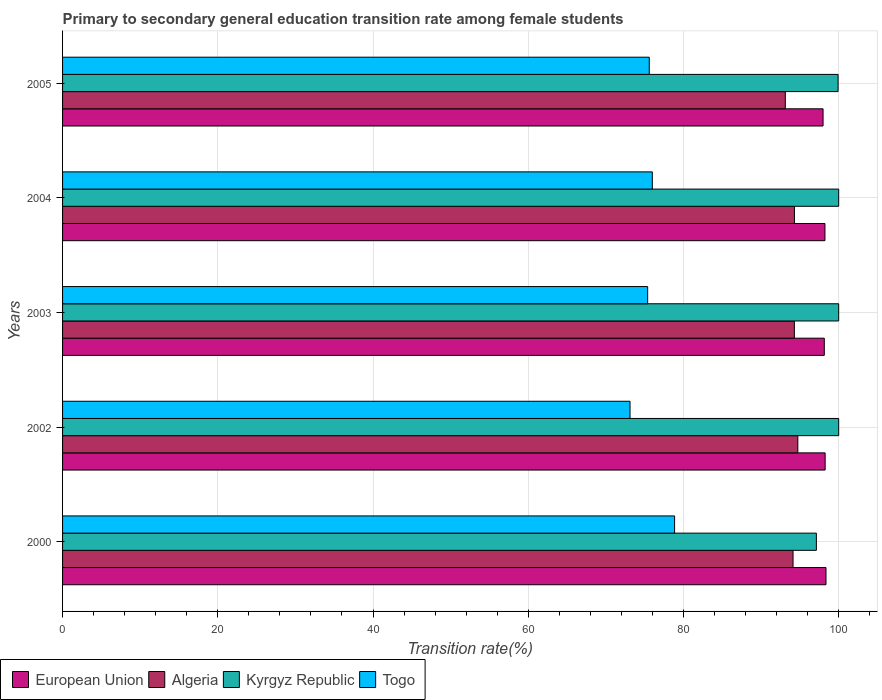What is the label of the 3rd group of bars from the top?
Make the answer very short. 2003. What is the transition rate in Algeria in 2003?
Provide a succinct answer. 94.29. Across all years, what is the maximum transition rate in Togo?
Your response must be concise. 78.86. Across all years, what is the minimum transition rate in European Union?
Ensure brevity in your answer.  97.99. In which year was the transition rate in Kyrgyz Republic maximum?
Your answer should be very brief. 2002. In which year was the transition rate in Togo minimum?
Give a very brief answer. 2002. What is the total transition rate in Kyrgyz Republic in the graph?
Keep it short and to the point. 497.05. What is the difference between the transition rate in Togo in 2003 and that in 2004?
Your answer should be very brief. -0.6. What is the difference between the transition rate in Kyrgyz Republic in 2004 and the transition rate in Algeria in 2003?
Your answer should be very brief. 5.71. What is the average transition rate in European Union per year?
Your response must be concise. 98.2. In the year 2005, what is the difference between the transition rate in Kyrgyz Republic and transition rate in European Union?
Provide a succinct answer. 1.94. What is the ratio of the transition rate in European Union in 2000 to that in 2002?
Offer a terse response. 1. What is the difference between the highest and the second highest transition rate in European Union?
Your answer should be compact. 0.11. What is the difference between the highest and the lowest transition rate in Kyrgyz Republic?
Keep it short and to the point. 2.87. In how many years, is the transition rate in European Union greater than the average transition rate in European Union taken over all years?
Your answer should be very brief. 3. Is it the case that in every year, the sum of the transition rate in European Union and transition rate in Algeria is greater than the sum of transition rate in Togo and transition rate in Kyrgyz Republic?
Ensure brevity in your answer.  No. What does the 2nd bar from the top in 2002 represents?
Provide a short and direct response. Kyrgyz Republic. How many bars are there?
Your answer should be compact. 20. What is the difference between two consecutive major ticks on the X-axis?
Your answer should be compact. 20. Are the values on the major ticks of X-axis written in scientific E-notation?
Your answer should be very brief. No. Does the graph contain any zero values?
Your answer should be compact. No. Does the graph contain grids?
Give a very brief answer. Yes. What is the title of the graph?
Ensure brevity in your answer.  Primary to secondary general education transition rate among female students. What is the label or title of the X-axis?
Offer a very short reply. Transition rate(%). What is the label or title of the Y-axis?
Provide a short and direct response. Years. What is the Transition rate(%) in European Union in 2000?
Keep it short and to the point. 98.37. What is the Transition rate(%) of Algeria in 2000?
Your answer should be very brief. 94.12. What is the Transition rate(%) of Kyrgyz Republic in 2000?
Keep it short and to the point. 97.13. What is the Transition rate(%) in Togo in 2000?
Make the answer very short. 78.86. What is the Transition rate(%) of European Union in 2002?
Your answer should be compact. 98.26. What is the Transition rate(%) of Algeria in 2002?
Your response must be concise. 94.74. What is the Transition rate(%) of Togo in 2002?
Offer a terse response. 73.12. What is the Transition rate(%) of European Union in 2003?
Give a very brief answer. 98.15. What is the Transition rate(%) of Algeria in 2003?
Offer a very short reply. 94.29. What is the Transition rate(%) in Togo in 2003?
Make the answer very short. 75.39. What is the Transition rate(%) of European Union in 2004?
Your answer should be compact. 98.23. What is the Transition rate(%) in Algeria in 2004?
Offer a terse response. 94.3. What is the Transition rate(%) of Kyrgyz Republic in 2004?
Keep it short and to the point. 100. What is the Transition rate(%) of Togo in 2004?
Ensure brevity in your answer.  75.99. What is the Transition rate(%) of European Union in 2005?
Give a very brief answer. 97.99. What is the Transition rate(%) of Algeria in 2005?
Give a very brief answer. 93.12. What is the Transition rate(%) of Kyrgyz Republic in 2005?
Ensure brevity in your answer.  99.92. What is the Transition rate(%) of Togo in 2005?
Offer a very short reply. 75.59. Across all years, what is the maximum Transition rate(%) of European Union?
Your answer should be compact. 98.37. Across all years, what is the maximum Transition rate(%) of Algeria?
Offer a terse response. 94.74. Across all years, what is the maximum Transition rate(%) of Togo?
Keep it short and to the point. 78.86. Across all years, what is the minimum Transition rate(%) in European Union?
Your answer should be compact. 97.99. Across all years, what is the minimum Transition rate(%) in Algeria?
Your answer should be very brief. 93.12. Across all years, what is the minimum Transition rate(%) in Kyrgyz Republic?
Offer a terse response. 97.13. Across all years, what is the minimum Transition rate(%) in Togo?
Offer a very short reply. 73.12. What is the total Transition rate(%) of European Union in the graph?
Your answer should be very brief. 490.98. What is the total Transition rate(%) of Algeria in the graph?
Ensure brevity in your answer.  470.57. What is the total Transition rate(%) in Kyrgyz Republic in the graph?
Your answer should be very brief. 497.05. What is the total Transition rate(%) of Togo in the graph?
Your answer should be compact. 378.94. What is the difference between the Transition rate(%) in European Union in 2000 and that in 2002?
Keep it short and to the point. 0.11. What is the difference between the Transition rate(%) in Algeria in 2000 and that in 2002?
Offer a terse response. -0.62. What is the difference between the Transition rate(%) of Kyrgyz Republic in 2000 and that in 2002?
Make the answer very short. -2.87. What is the difference between the Transition rate(%) of Togo in 2000 and that in 2002?
Provide a succinct answer. 5.74. What is the difference between the Transition rate(%) of European Union in 2000 and that in 2003?
Ensure brevity in your answer.  0.22. What is the difference between the Transition rate(%) in Algeria in 2000 and that in 2003?
Make the answer very short. -0.17. What is the difference between the Transition rate(%) of Kyrgyz Republic in 2000 and that in 2003?
Provide a succinct answer. -2.87. What is the difference between the Transition rate(%) of Togo in 2000 and that in 2003?
Your answer should be compact. 3.47. What is the difference between the Transition rate(%) of European Union in 2000 and that in 2004?
Offer a very short reply. 0.13. What is the difference between the Transition rate(%) in Algeria in 2000 and that in 2004?
Your response must be concise. -0.18. What is the difference between the Transition rate(%) in Kyrgyz Republic in 2000 and that in 2004?
Your answer should be compact. -2.87. What is the difference between the Transition rate(%) in Togo in 2000 and that in 2004?
Your answer should be very brief. 2.87. What is the difference between the Transition rate(%) of European Union in 2000 and that in 2005?
Your answer should be very brief. 0.38. What is the difference between the Transition rate(%) of Algeria in 2000 and that in 2005?
Give a very brief answer. 1. What is the difference between the Transition rate(%) in Kyrgyz Republic in 2000 and that in 2005?
Give a very brief answer. -2.8. What is the difference between the Transition rate(%) in Togo in 2000 and that in 2005?
Ensure brevity in your answer.  3.26. What is the difference between the Transition rate(%) of European Union in 2002 and that in 2003?
Make the answer very short. 0.11. What is the difference between the Transition rate(%) of Algeria in 2002 and that in 2003?
Your answer should be compact. 0.45. What is the difference between the Transition rate(%) in Kyrgyz Republic in 2002 and that in 2003?
Provide a succinct answer. 0. What is the difference between the Transition rate(%) of Togo in 2002 and that in 2003?
Your answer should be compact. -2.27. What is the difference between the Transition rate(%) in European Union in 2002 and that in 2004?
Offer a very short reply. 0.02. What is the difference between the Transition rate(%) in Algeria in 2002 and that in 2004?
Give a very brief answer. 0.44. What is the difference between the Transition rate(%) of Kyrgyz Republic in 2002 and that in 2004?
Provide a succinct answer. 0. What is the difference between the Transition rate(%) of Togo in 2002 and that in 2004?
Provide a succinct answer. -2.87. What is the difference between the Transition rate(%) of European Union in 2002 and that in 2005?
Ensure brevity in your answer.  0.27. What is the difference between the Transition rate(%) of Algeria in 2002 and that in 2005?
Ensure brevity in your answer.  1.61. What is the difference between the Transition rate(%) in Kyrgyz Republic in 2002 and that in 2005?
Your answer should be very brief. 0.08. What is the difference between the Transition rate(%) of Togo in 2002 and that in 2005?
Make the answer very short. -2.48. What is the difference between the Transition rate(%) of European Union in 2003 and that in 2004?
Make the answer very short. -0.09. What is the difference between the Transition rate(%) of Algeria in 2003 and that in 2004?
Your answer should be very brief. -0.01. What is the difference between the Transition rate(%) of Togo in 2003 and that in 2004?
Your answer should be compact. -0.6. What is the difference between the Transition rate(%) of European Union in 2003 and that in 2005?
Your answer should be very brief. 0.16. What is the difference between the Transition rate(%) of Algeria in 2003 and that in 2005?
Your response must be concise. 1.17. What is the difference between the Transition rate(%) of Kyrgyz Republic in 2003 and that in 2005?
Provide a short and direct response. 0.08. What is the difference between the Transition rate(%) of Togo in 2003 and that in 2005?
Ensure brevity in your answer.  -0.21. What is the difference between the Transition rate(%) in European Union in 2004 and that in 2005?
Provide a succinct answer. 0.25. What is the difference between the Transition rate(%) in Algeria in 2004 and that in 2005?
Your answer should be compact. 1.18. What is the difference between the Transition rate(%) of Kyrgyz Republic in 2004 and that in 2005?
Ensure brevity in your answer.  0.08. What is the difference between the Transition rate(%) of Togo in 2004 and that in 2005?
Give a very brief answer. 0.39. What is the difference between the Transition rate(%) in European Union in 2000 and the Transition rate(%) in Algeria in 2002?
Provide a succinct answer. 3.63. What is the difference between the Transition rate(%) in European Union in 2000 and the Transition rate(%) in Kyrgyz Republic in 2002?
Your answer should be very brief. -1.63. What is the difference between the Transition rate(%) of European Union in 2000 and the Transition rate(%) of Togo in 2002?
Ensure brevity in your answer.  25.25. What is the difference between the Transition rate(%) in Algeria in 2000 and the Transition rate(%) in Kyrgyz Republic in 2002?
Make the answer very short. -5.88. What is the difference between the Transition rate(%) of Algeria in 2000 and the Transition rate(%) of Togo in 2002?
Provide a short and direct response. 21. What is the difference between the Transition rate(%) of Kyrgyz Republic in 2000 and the Transition rate(%) of Togo in 2002?
Your answer should be very brief. 24.01. What is the difference between the Transition rate(%) of European Union in 2000 and the Transition rate(%) of Algeria in 2003?
Your answer should be compact. 4.08. What is the difference between the Transition rate(%) in European Union in 2000 and the Transition rate(%) in Kyrgyz Republic in 2003?
Provide a succinct answer. -1.63. What is the difference between the Transition rate(%) in European Union in 2000 and the Transition rate(%) in Togo in 2003?
Ensure brevity in your answer.  22.98. What is the difference between the Transition rate(%) of Algeria in 2000 and the Transition rate(%) of Kyrgyz Republic in 2003?
Your answer should be very brief. -5.88. What is the difference between the Transition rate(%) in Algeria in 2000 and the Transition rate(%) in Togo in 2003?
Provide a short and direct response. 18.73. What is the difference between the Transition rate(%) in Kyrgyz Republic in 2000 and the Transition rate(%) in Togo in 2003?
Provide a succinct answer. 21.74. What is the difference between the Transition rate(%) of European Union in 2000 and the Transition rate(%) of Algeria in 2004?
Make the answer very short. 4.07. What is the difference between the Transition rate(%) of European Union in 2000 and the Transition rate(%) of Kyrgyz Republic in 2004?
Provide a short and direct response. -1.63. What is the difference between the Transition rate(%) in European Union in 2000 and the Transition rate(%) in Togo in 2004?
Your answer should be compact. 22.38. What is the difference between the Transition rate(%) of Algeria in 2000 and the Transition rate(%) of Kyrgyz Republic in 2004?
Give a very brief answer. -5.88. What is the difference between the Transition rate(%) in Algeria in 2000 and the Transition rate(%) in Togo in 2004?
Your answer should be very brief. 18.13. What is the difference between the Transition rate(%) in Kyrgyz Republic in 2000 and the Transition rate(%) in Togo in 2004?
Offer a terse response. 21.14. What is the difference between the Transition rate(%) in European Union in 2000 and the Transition rate(%) in Algeria in 2005?
Your response must be concise. 5.24. What is the difference between the Transition rate(%) in European Union in 2000 and the Transition rate(%) in Kyrgyz Republic in 2005?
Give a very brief answer. -1.56. What is the difference between the Transition rate(%) in European Union in 2000 and the Transition rate(%) in Togo in 2005?
Your response must be concise. 22.77. What is the difference between the Transition rate(%) in Algeria in 2000 and the Transition rate(%) in Kyrgyz Republic in 2005?
Offer a terse response. -5.8. What is the difference between the Transition rate(%) in Algeria in 2000 and the Transition rate(%) in Togo in 2005?
Your response must be concise. 18.53. What is the difference between the Transition rate(%) of Kyrgyz Republic in 2000 and the Transition rate(%) of Togo in 2005?
Give a very brief answer. 21.53. What is the difference between the Transition rate(%) of European Union in 2002 and the Transition rate(%) of Algeria in 2003?
Give a very brief answer. 3.97. What is the difference between the Transition rate(%) of European Union in 2002 and the Transition rate(%) of Kyrgyz Republic in 2003?
Your response must be concise. -1.74. What is the difference between the Transition rate(%) of European Union in 2002 and the Transition rate(%) of Togo in 2003?
Keep it short and to the point. 22.87. What is the difference between the Transition rate(%) in Algeria in 2002 and the Transition rate(%) in Kyrgyz Republic in 2003?
Offer a very short reply. -5.26. What is the difference between the Transition rate(%) in Algeria in 2002 and the Transition rate(%) in Togo in 2003?
Your response must be concise. 19.35. What is the difference between the Transition rate(%) in Kyrgyz Republic in 2002 and the Transition rate(%) in Togo in 2003?
Your answer should be very brief. 24.61. What is the difference between the Transition rate(%) in European Union in 2002 and the Transition rate(%) in Algeria in 2004?
Give a very brief answer. 3.96. What is the difference between the Transition rate(%) in European Union in 2002 and the Transition rate(%) in Kyrgyz Republic in 2004?
Provide a succinct answer. -1.74. What is the difference between the Transition rate(%) of European Union in 2002 and the Transition rate(%) of Togo in 2004?
Offer a terse response. 22.27. What is the difference between the Transition rate(%) in Algeria in 2002 and the Transition rate(%) in Kyrgyz Republic in 2004?
Make the answer very short. -5.26. What is the difference between the Transition rate(%) in Algeria in 2002 and the Transition rate(%) in Togo in 2004?
Offer a very short reply. 18.75. What is the difference between the Transition rate(%) of Kyrgyz Republic in 2002 and the Transition rate(%) of Togo in 2004?
Your response must be concise. 24.01. What is the difference between the Transition rate(%) of European Union in 2002 and the Transition rate(%) of Algeria in 2005?
Give a very brief answer. 5.13. What is the difference between the Transition rate(%) in European Union in 2002 and the Transition rate(%) in Kyrgyz Republic in 2005?
Make the answer very short. -1.67. What is the difference between the Transition rate(%) in European Union in 2002 and the Transition rate(%) in Togo in 2005?
Ensure brevity in your answer.  22.66. What is the difference between the Transition rate(%) in Algeria in 2002 and the Transition rate(%) in Kyrgyz Republic in 2005?
Keep it short and to the point. -5.19. What is the difference between the Transition rate(%) in Algeria in 2002 and the Transition rate(%) in Togo in 2005?
Offer a terse response. 19.14. What is the difference between the Transition rate(%) in Kyrgyz Republic in 2002 and the Transition rate(%) in Togo in 2005?
Keep it short and to the point. 24.41. What is the difference between the Transition rate(%) in European Union in 2003 and the Transition rate(%) in Algeria in 2004?
Offer a terse response. 3.85. What is the difference between the Transition rate(%) of European Union in 2003 and the Transition rate(%) of Kyrgyz Republic in 2004?
Provide a succinct answer. -1.85. What is the difference between the Transition rate(%) of European Union in 2003 and the Transition rate(%) of Togo in 2004?
Provide a succinct answer. 22.16. What is the difference between the Transition rate(%) of Algeria in 2003 and the Transition rate(%) of Kyrgyz Republic in 2004?
Your response must be concise. -5.71. What is the difference between the Transition rate(%) in Algeria in 2003 and the Transition rate(%) in Togo in 2004?
Provide a succinct answer. 18.3. What is the difference between the Transition rate(%) in Kyrgyz Republic in 2003 and the Transition rate(%) in Togo in 2004?
Provide a succinct answer. 24.01. What is the difference between the Transition rate(%) in European Union in 2003 and the Transition rate(%) in Algeria in 2005?
Your answer should be very brief. 5.02. What is the difference between the Transition rate(%) of European Union in 2003 and the Transition rate(%) of Kyrgyz Republic in 2005?
Make the answer very short. -1.78. What is the difference between the Transition rate(%) of European Union in 2003 and the Transition rate(%) of Togo in 2005?
Offer a very short reply. 22.55. What is the difference between the Transition rate(%) in Algeria in 2003 and the Transition rate(%) in Kyrgyz Republic in 2005?
Your answer should be very brief. -5.63. What is the difference between the Transition rate(%) in Algeria in 2003 and the Transition rate(%) in Togo in 2005?
Keep it short and to the point. 18.7. What is the difference between the Transition rate(%) in Kyrgyz Republic in 2003 and the Transition rate(%) in Togo in 2005?
Offer a terse response. 24.41. What is the difference between the Transition rate(%) of European Union in 2004 and the Transition rate(%) of Algeria in 2005?
Your answer should be compact. 5.11. What is the difference between the Transition rate(%) of European Union in 2004 and the Transition rate(%) of Kyrgyz Republic in 2005?
Provide a succinct answer. -1.69. What is the difference between the Transition rate(%) of European Union in 2004 and the Transition rate(%) of Togo in 2005?
Provide a succinct answer. 22.64. What is the difference between the Transition rate(%) of Algeria in 2004 and the Transition rate(%) of Kyrgyz Republic in 2005?
Make the answer very short. -5.63. What is the difference between the Transition rate(%) of Algeria in 2004 and the Transition rate(%) of Togo in 2005?
Keep it short and to the point. 18.7. What is the difference between the Transition rate(%) in Kyrgyz Republic in 2004 and the Transition rate(%) in Togo in 2005?
Your answer should be very brief. 24.41. What is the average Transition rate(%) of European Union per year?
Provide a short and direct response. 98.2. What is the average Transition rate(%) of Algeria per year?
Your answer should be compact. 94.11. What is the average Transition rate(%) of Kyrgyz Republic per year?
Offer a very short reply. 99.41. What is the average Transition rate(%) of Togo per year?
Give a very brief answer. 75.79. In the year 2000, what is the difference between the Transition rate(%) of European Union and Transition rate(%) of Algeria?
Give a very brief answer. 4.25. In the year 2000, what is the difference between the Transition rate(%) of European Union and Transition rate(%) of Kyrgyz Republic?
Make the answer very short. 1.24. In the year 2000, what is the difference between the Transition rate(%) of European Union and Transition rate(%) of Togo?
Offer a very short reply. 19.51. In the year 2000, what is the difference between the Transition rate(%) in Algeria and Transition rate(%) in Kyrgyz Republic?
Provide a short and direct response. -3. In the year 2000, what is the difference between the Transition rate(%) of Algeria and Transition rate(%) of Togo?
Your answer should be compact. 15.26. In the year 2000, what is the difference between the Transition rate(%) of Kyrgyz Republic and Transition rate(%) of Togo?
Give a very brief answer. 18.27. In the year 2002, what is the difference between the Transition rate(%) in European Union and Transition rate(%) in Algeria?
Provide a short and direct response. 3.52. In the year 2002, what is the difference between the Transition rate(%) of European Union and Transition rate(%) of Kyrgyz Republic?
Give a very brief answer. -1.74. In the year 2002, what is the difference between the Transition rate(%) in European Union and Transition rate(%) in Togo?
Make the answer very short. 25.14. In the year 2002, what is the difference between the Transition rate(%) in Algeria and Transition rate(%) in Kyrgyz Republic?
Ensure brevity in your answer.  -5.26. In the year 2002, what is the difference between the Transition rate(%) of Algeria and Transition rate(%) of Togo?
Keep it short and to the point. 21.62. In the year 2002, what is the difference between the Transition rate(%) in Kyrgyz Republic and Transition rate(%) in Togo?
Your answer should be compact. 26.88. In the year 2003, what is the difference between the Transition rate(%) in European Union and Transition rate(%) in Algeria?
Make the answer very short. 3.86. In the year 2003, what is the difference between the Transition rate(%) of European Union and Transition rate(%) of Kyrgyz Republic?
Ensure brevity in your answer.  -1.85. In the year 2003, what is the difference between the Transition rate(%) in European Union and Transition rate(%) in Togo?
Ensure brevity in your answer.  22.76. In the year 2003, what is the difference between the Transition rate(%) in Algeria and Transition rate(%) in Kyrgyz Republic?
Your response must be concise. -5.71. In the year 2003, what is the difference between the Transition rate(%) of Algeria and Transition rate(%) of Togo?
Your answer should be compact. 18.9. In the year 2003, what is the difference between the Transition rate(%) in Kyrgyz Republic and Transition rate(%) in Togo?
Keep it short and to the point. 24.61. In the year 2004, what is the difference between the Transition rate(%) in European Union and Transition rate(%) in Algeria?
Your answer should be compact. 3.93. In the year 2004, what is the difference between the Transition rate(%) in European Union and Transition rate(%) in Kyrgyz Republic?
Your response must be concise. -1.77. In the year 2004, what is the difference between the Transition rate(%) of European Union and Transition rate(%) of Togo?
Provide a succinct answer. 22.24. In the year 2004, what is the difference between the Transition rate(%) of Algeria and Transition rate(%) of Kyrgyz Republic?
Provide a succinct answer. -5.7. In the year 2004, what is the difference between the Transition rate(%) of Algeria and Transition rate(%) of Togo?
Ensure brevity in your answer.  18.31. In the year 2004, what is the difference between the Transition rate(%) in Kyrgyz Republic and Transition rate(%) in Togo?
Provide a succinct answer. 24.01. In the year 2005, what is the difference between the Transition rate(%) in European Union and Transition rate(%) in Algeria?
Provide a short and direct response. 4.86. In the year 2005, what is the difference between the Transition rate(%) of European Union and Transition rate(%) of Kyrgyz Republic?
Your response must be concise. -1.94. In the year 2005, what is the difference between the Transition rate(%) of European Union and Transition rate(%) of Togo?
Your response must be concise. 22.39. In the year 2005, what is the difference between the Transition rate(%) in Algeria and Transition rate(%) in Kyrgyz Republic?
Offer a terse response. -6.8. In the year 2005, what is the difference between the Transition rate(%) of Algeria and Transition rate(%) of Togo?
Your response must be concise. 17.53. In the year 2005, what is the difference between the Transition rate(%) of Kyrgyz Republic and Transition rate(%) of Togo?
Provide a succinct answer. 24.33. What is the ratio of the Transition rate(%) of Algeria in 2000 to that in 2002?
Offer a very short reply. 0.99. What is the ratio of the Transition rate(%) in Kyrgyz Republic in 2000 to that in 2002?
Give a very brief answer. 0.97. What is the ratio of the Transition rate(%) of Togo in 2000 to that in 2002?
Provide a succinct answer. 1.08. What is the ratio of the Transition rate(%) of European Union in 2000 to that in 2003?
Keep it short and to the point. 1. What is the ratio of the Transition rate(%) in Kyrgyz Republic in 2000 to that in 2003?
Ensure brevity in your answer.  0.97. What is the ratio of the Transition rate(%) in Togo in 2000 to that in 2003?
Keep it short and to the point. 1.05. What is the ratio of the Transition rate(%) of European Union in 2000 to that in 2004?
Your response must be concise. 1. What is the ratio of the Transition rate(%) of Algeria in 2000 to that in 2004?
Your answer should be very brief. 1. What is the ratio of the Transition rate(%) of Kyrgyz Republic in 2000 to that in 2004?
Provide a succinct answer. 0.97. What is the ratio of the Transition rate(%) in Togo in 2000 to that in 2004?
Your response must be concise. 1.04. What is the ratio of the Transition rate(%) of European Union in 2000 to that in 2005?
Your answer should be compact. 1. What is the ratio of the Transition rate(%) in Algeria in 2000 to that in 2005?
Provide a succinct answer. 1.01. What is the ratio of the Transition rate(%) of Togo in 2000 to that in 2005?
Make the answer very short. 1.04. What is the ratio of the Transition rate(%) in Algeria in 2002 to that in 2003?
Ensure brevity in your answer.  1. What is the ratio of the Transition rate(%) of Togo in 2002 to that in 2003?
Your answer should be compact. 0.97. What is the ratio of the Transition rate(%) of Kyrgyz Republic in 2002 to that in 2004?
Your answer should be very brief. 1. What is the ratio of the Transition rate(%) in Togo in 2002 to that in 2004?
Make the answer very short. 0.96. What is the ratio of the Transition rate(%) of European Union in 2002 to that in 2005?
Your response must be concise. 1. What is the ratio of the Transition rate(%) in Algeria in 2002 to that in 2005?
Offer a very short reply. 1.02. What is the ratio of the Transition rate(%) in Kyrgyz Republic in 2002 to that in 2005?
Ensure brevity in your answer.  1. What is the ratio of the Transition rate(%) of Togo in 2002 to that in 2005?
Ensure brevity in your answer.  0.97. What is the ratio of the Transition rate(%) in Algeria in 2003 to that in 2005?
Your response must be concise. 1.01. What is the ratio of the Transition rate(%) of Algeria in 2004 to that in 2005?
Your answer should be very brief. 1.01. What is the ratio of the Transition rate(%) of Kyrgyz Republic in 2004 to that in 2005?
Keep it short and to the point. 1. What is the ratio of the Transition rate(%) in Togo in 2004 to that in 2005?
Give a very brief answer. 1.01. What is the difference between the highest and the second highest Transition rate(%) in European Union?
Ensure brevity in your answer.  0.11. What is the difference between the highest and the second highest Transition rate(%) of Algeria?
Keep it short and to the point. 0.44. What is the difference between the highest and the second highest Transition rate(%) in Togo?
Your answer should be compact. 2.87. What is the difference between the highest and the lowest Transition rate(%) in European Union?
Offer a very short reply. 0.38. What is the difference between the highest and the lowest Transition rate(%) in Algeria?
Provide a succinct answer. 1.61. What is the difference between the highest and the lowest Transition rate(%) of Kyrgyz Republic?
Offer a very short reply. 2.87. What is the difference between the highest and the lowest Transition rate(%) in Togo?
Make the answer very short. 5.74. 